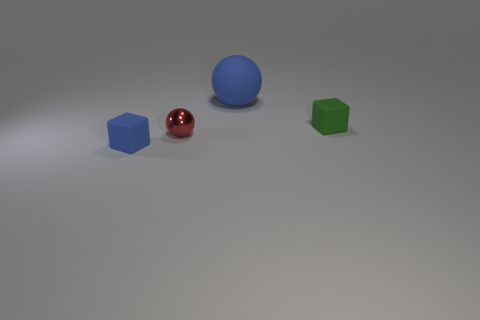Add 1 gray rubber spheres. How many objects exist? 5 Subtract 0 cyan cylinders. How many objects are left? 4 Subtract 2 blocks. How many blocks are left? 0 Subtract all cyan cubes. Subtract all gray cylinders. How many cubes are left? 2 Subtract all gray blocks. How many blue spheres are left? 1 Subtract all large balls. Subtract all tiny blue things. How many objects are left? 2 Add 4 tiny blocks. How many tiny blocks are left? 6 Add 3 matte objects. How many matte objects exist? 6 